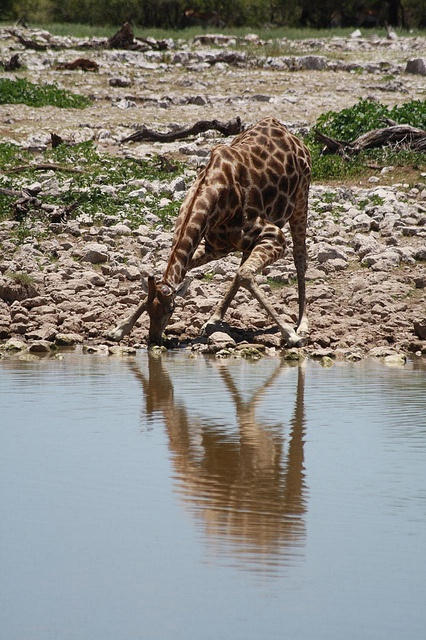Describe the objects in this image and their specific colors. I can see a giraffe in black, maroon, and gray tones in this image. 